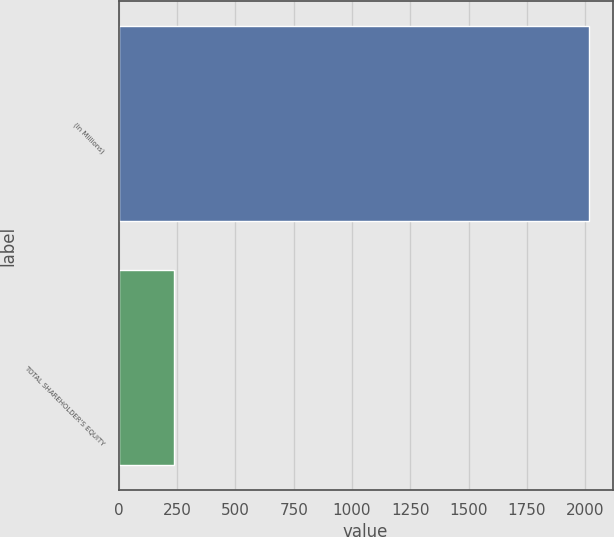<chart> <loc_0><loc_0><loc_500><loc_500><bar_chart><fcel>(In Millions)<fcel>TOTAL SHAREHOLDER'S EQUITY<nl><fcel>2016<fcel>235<nl></chart> 